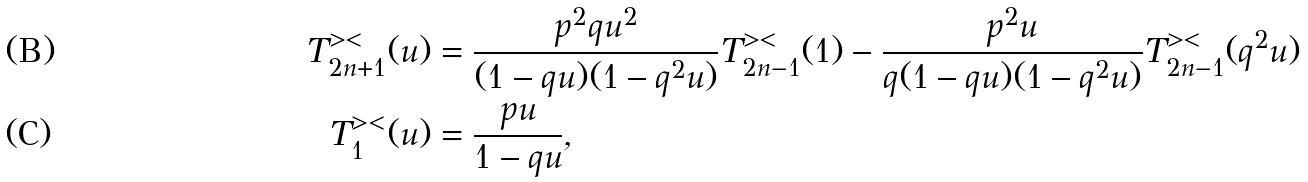Convert formula to latex. <formula><loc_0><loc_0><loc_500><loc_500>T ^ { > < } _ { 2 n + 1 } ( u ) & = \frac { p ^ { 2 } q u ^ { 2 } } { ( 1 - q u ) ( 1 - q ^ { 2 } u ) } T ^ { > < } _ { 2 n - 1 } ( 1 ) - \frac { p ^ { 2 } u } { q ( 1 - q u ) ( 1 - q ^ { 2 } u ) } T ^ { > < } _ { 2 n - 1 } ( q ^ { 2 } u ) \\ T ^ { > < } _ { 1 } ( u ) & = \frac { p u } { 1 - q u } ,</formula> 